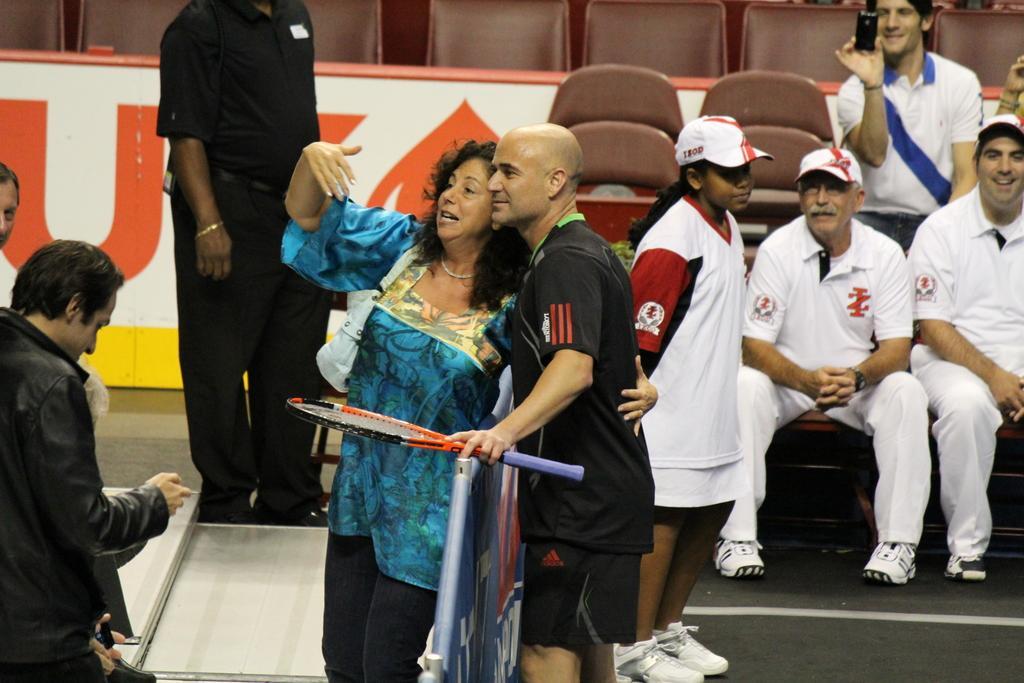Could you give a brief overview of what you see in this image? In this picture we can see a tennis player wearing a black t-shirt and shorts is standing and taking a selfie with the woman. Behind there are some players wearing a white t-shirt is sitting on the chair and looking to them. In the background we can see some chairs. 